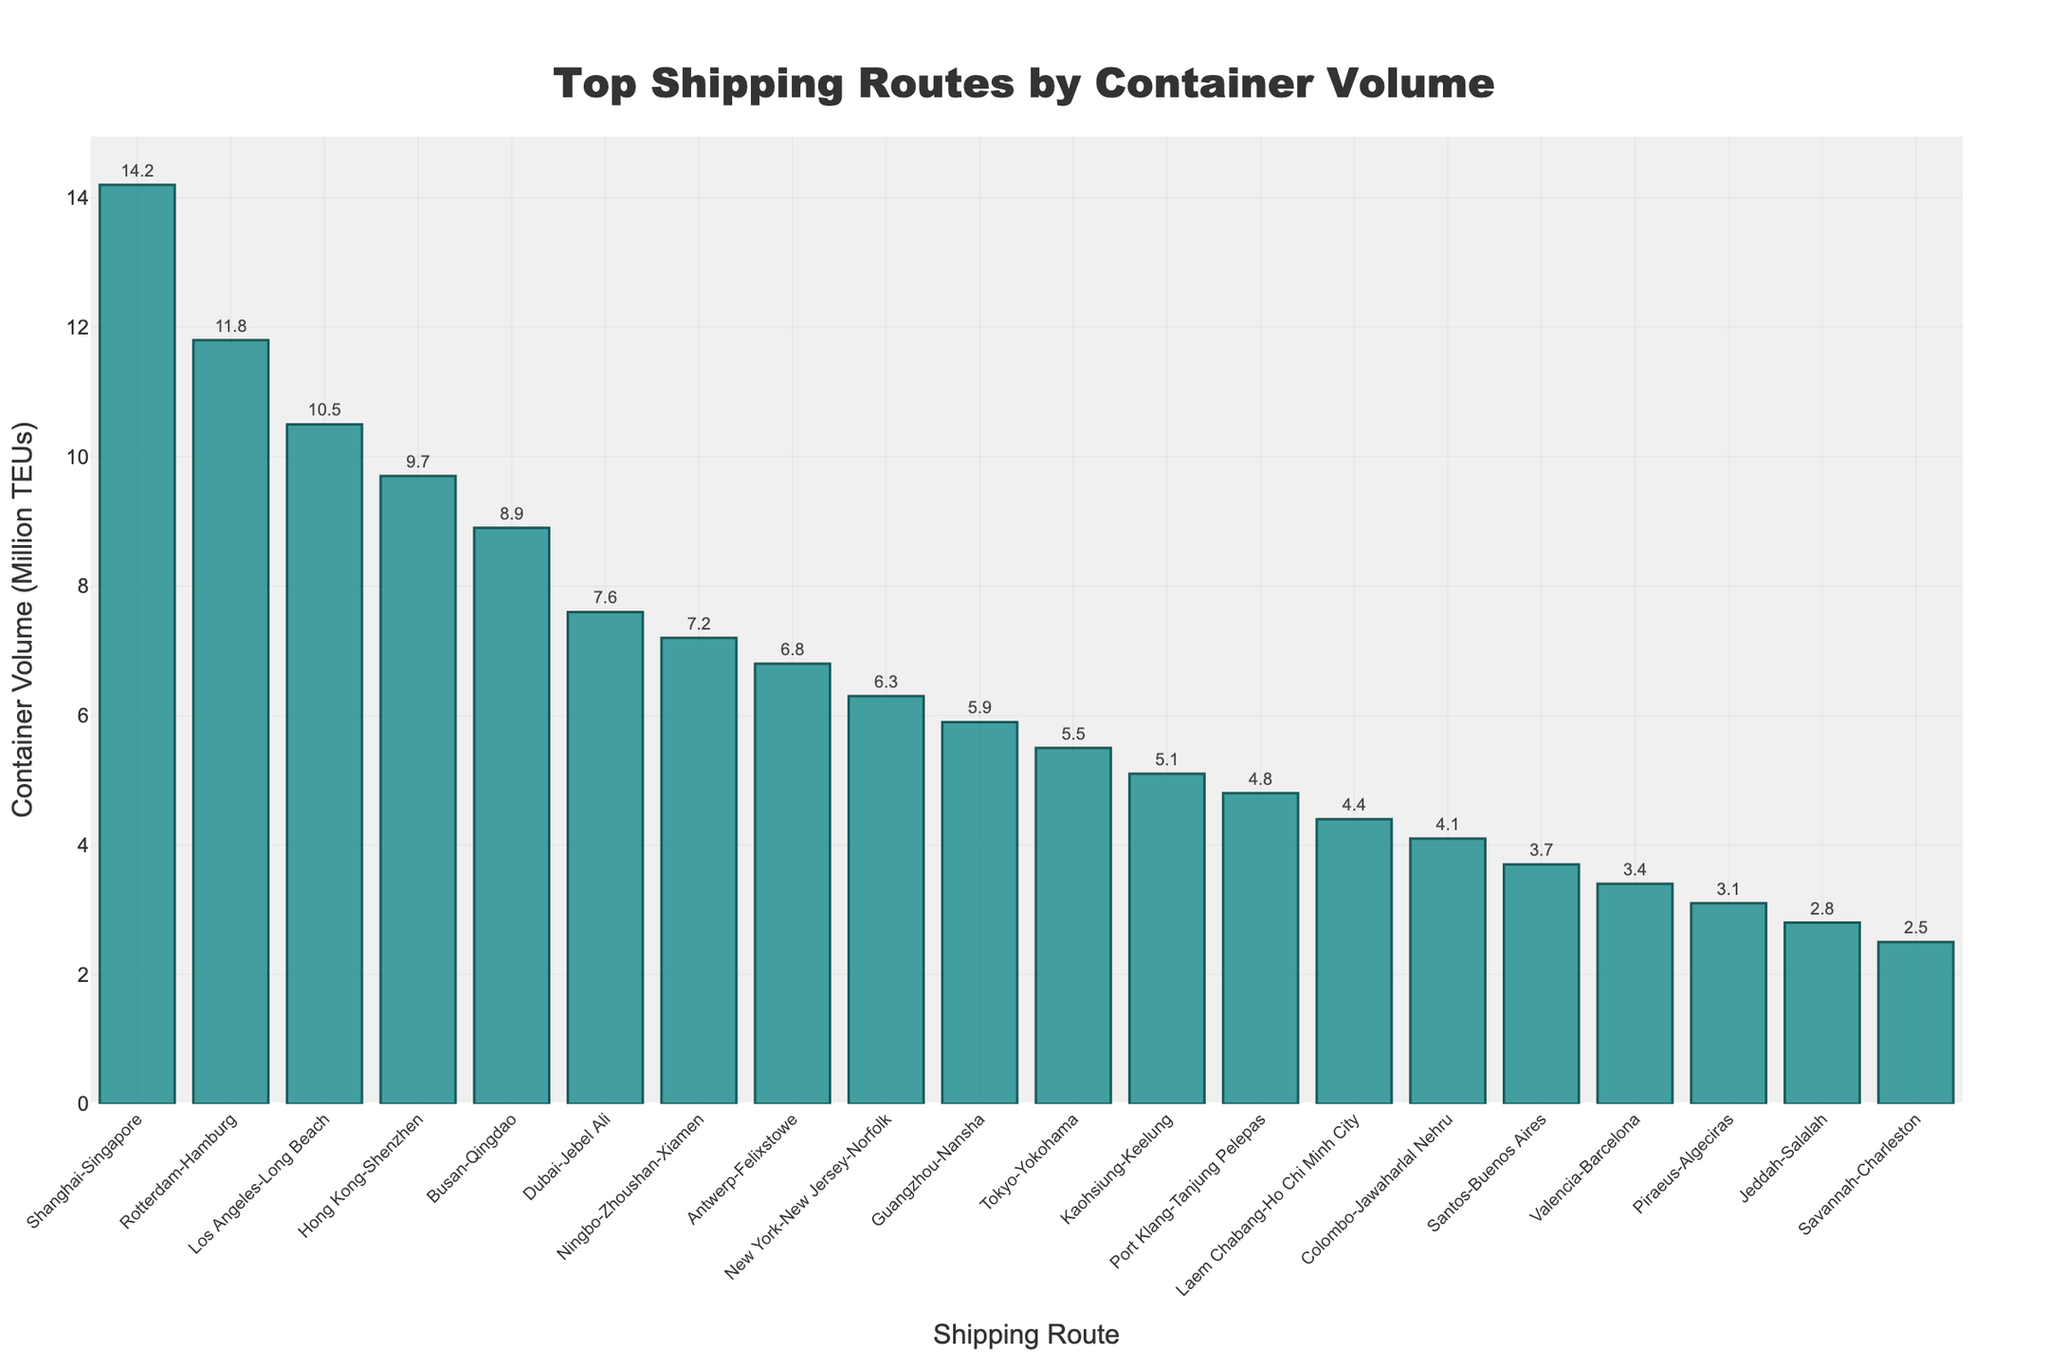Which route has the highest container volume? The bar representing the Shanghai-Singapore route is the tallest, indicating it has the highest container volume.
Answer: Shanghai-Singapore What is the combined container volume of Rotterdam-Hamburg and Los Angeles-Long Beach? The container volume for Rotterdam-Hamburg is 11.8 million TEUs, and for Los Angeles-Long Beach, it is 10.5 million TEUs. The combined volume is 11.8 + 10.5 = 22.3 million TEUs.
Answer: 22.3 million TEUs Which route has a lower container volume: Colombo-Jawaharlal Nehru or Santos-Buenos Aires? By comparing the heights of the bars, the Santos-Buenos Aires route, which is taller, indicates it has a higher container volume than the Colombo-Jawaharlal Nehru route. Therefore, Colombo-Jawaharlal Nehru has a lower volume.
Answer: Colombo-Jawaharlal Nehru What is the total container volume for the top three shipping routes? The container volumes are 14.2 million TEUs (Shanghai-Singapore), 11.8 million TEUs (Rotterdam-Hamburg), and 10.5 million TEUs (Los Angeles-Long Beach). The total is 14.2 + 11.8 + 10.5 = 36.5 million TEUs.
Answer: 36.5 million TEUs Among the listed routes, which one has the lowest container volume? The bar representing the Savannah-Charleston route is the shortest, indicating it has the lowest container volume.
Answer: Savannah-Charleston By how much does the container volume of Hong Kong-Shenzhen exceed that of New York-New Jersey-Norfolk? The container volume for Hong Kong-Shenzhen is 9.7 million TEUs, and for New York-New Jersey-Norfolk, it is 6.3 million TEUs. The difference is 9.7 - 6.3 = 3.4 million TEUs.
Answer: 3.4 million TEUs How many shipping routes have a container volume greater than 5 million TEUs? The bars representing the routes from Shanghai-Singapore to New York-New Jersey-Norfolk are above the 5 million TEUs mark. There are 10 routes in total that meet this criterion.
Answer: 10 routes What's the average container volume for the routes between Tokyo-Yokohama, Kaohsiung-Keelung, and Port Klang-Tanjung Pelepas? The container volumes are 5.5 million TEUs (Tokyo-Yokohama), 5.1 million TEUs (Kaohsiung-Keelung), and 4.8 million TEUs (Port Klang-Tanjung Pelepas). The total is 5.5 + 5.1 + 4.8 = 15.4; the average is 15.4 / 3 = 5.13 million TEUs.
Answer: 5.13 million TEUs How does the container volume of Dubai-Jebel Ali compare to that of Ningbo-Zhoushan-Xiamen? The bar for Dubai-Jebel Ali is taller at 7.6 million TEUs, while the bar for Ningbo-Zhoushan-Xiamen is 7.2 million TEUs, showing Dubai-Jebel Ali has a higher volume.
Answer: Dubai-Jebel Ali Which route has a container volume closest to 4 million TEUs? The bar for Colombo-Jawaharlal Nehru shows a volume of 4.1 million TEUs, which is the closest to 4 million TEUs among the listed routes.
Answer: Colombo-Jawaharlal Nehru What is the difference between the container volumes of the highest and lowest routes? The container volume for Shanghai-Singapore (highest) is 14.2 million TEUs, and for Savannah-Charleston (lowest) it is 2.5 million TEUs. The difference is 14.2 - 2.5 = 11.7 million TEUs.
Answer: 11.7 million TEUs 